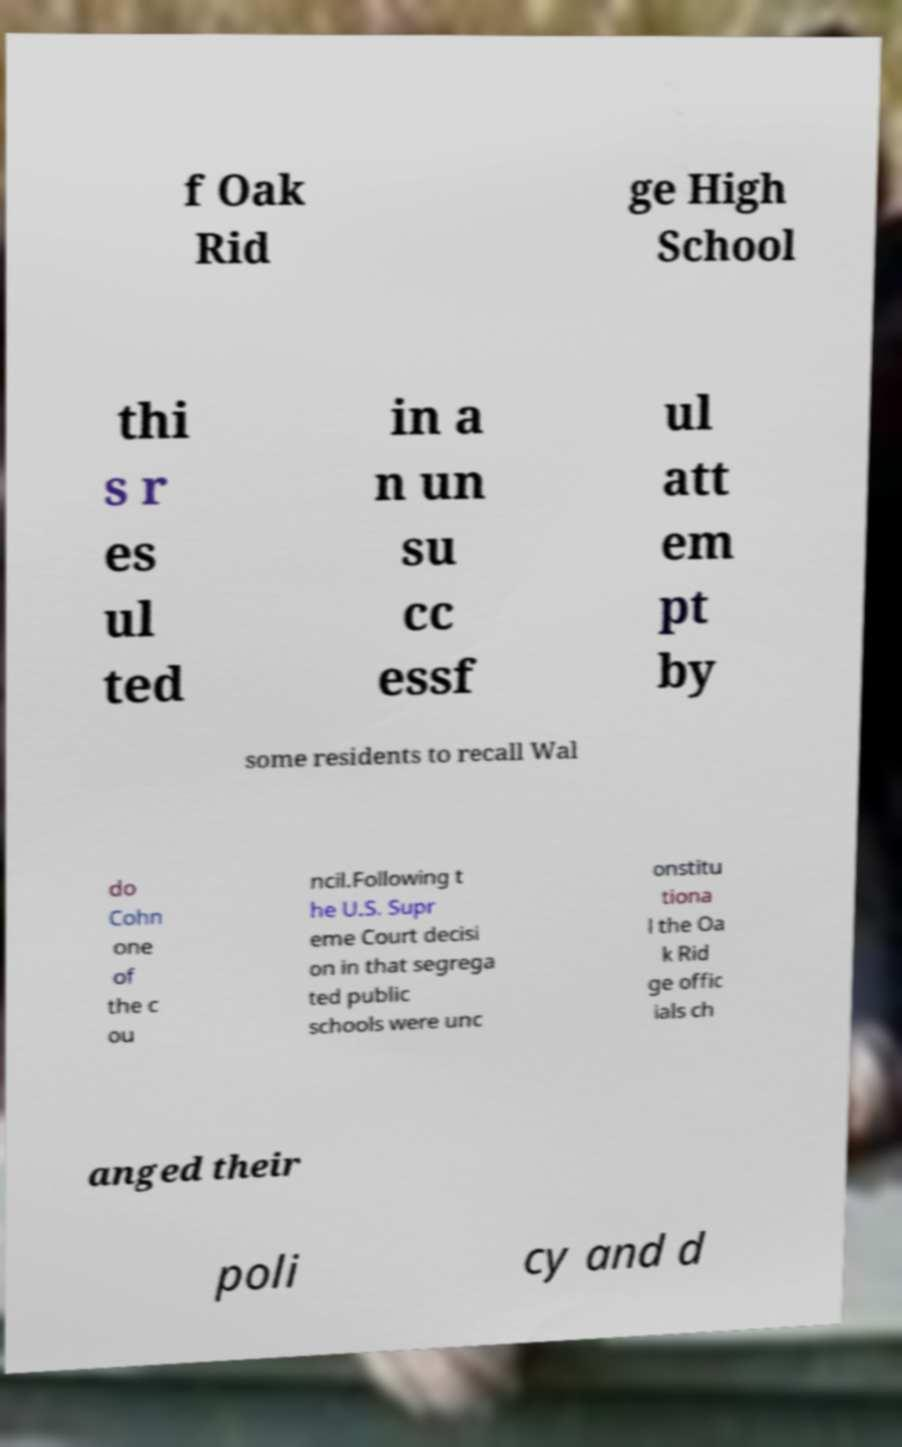What messages or text are displayed in this image? I need them in a readable, typed format. f Oak Rid ge High School thi s r es ul ted in a n un su cc essf ul att em pt by some residents to recall Wal do Cohn one of the c ou ncil.Following t he U.S. Supr eme Court decisi on in that segrega ted public schools were unc onstitu tiona l the Oa k Rid ge offic ials ch anged their poli cy and d 